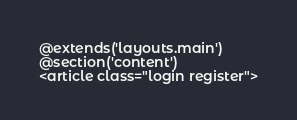<code> <loc_0><loc_0><loc_500><loc_500><_PHP_>@extends('layouts.main')
@section('content')
<article class="login register"></code> 